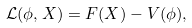<formula> <loc_0><loc_0><loc_500><loc_500>\mathcal { L } ( \phi , X ) = F ( X ) - V ( \phi ) ,</formula> 